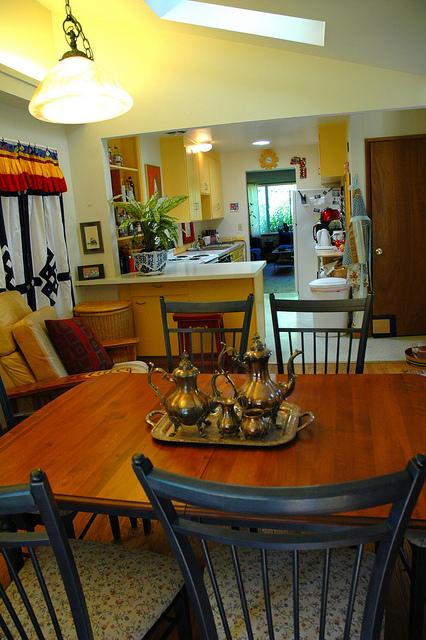What is on the counter behind the table?
Answer briefly. Plant. Are there mats on the table?
Concise answer only. No. What is on the table?
Be succinct. Tea set. What material is the tea set made of?
Answer briefly. Silver. 